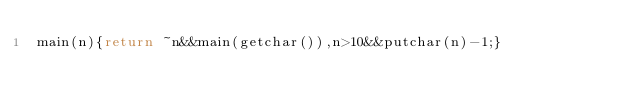<code> <loc_0><loc_0><loc_500><loc_500><_C_>main(n){return ~n&&main(getchar()),n>10&&putchar(n)-1;}</code> 